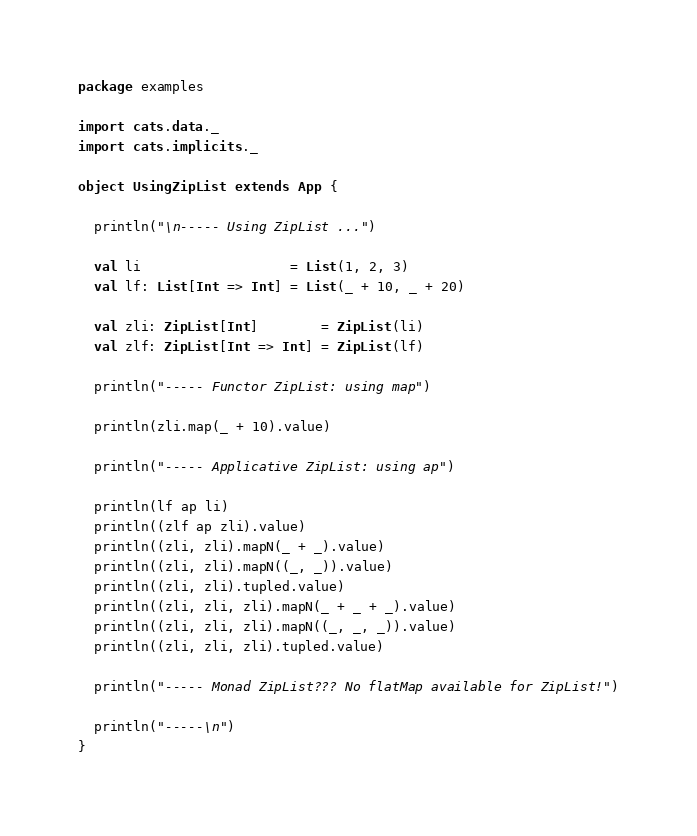<code> <loc_0><loc_0><loc_500><loc_500><_Scala_>package examples

import cats.data._
import cats.implicits._

object UsingZipList extends App {

  println("\n----- Using ZipList ...")

  val li                   = List(1, 2, 3)
  val lf: List[Int => Int] = List(_ + 10, _ + 20)

  val zli: ZipList[Int]        = ZipList(li)
  val zlf: ZipList[Int => Int] = ZipList(lf)

  println("----- Functor ZipList: using map")

  println(zli.map(_ + 10).value)

  println("----- Applicative ZipList: using ap")

  println(lf ap li)
  println((zlf ap zli).value)
  println((zli, zli).mapN(_ + _).value)
  println((zli, zli).mapN((_, _)).value)
  println((zli, zli).tupled.value)
  println((zli, zli, zli).mapN(_ + _ + _).value)
  println((zli, zli, zli).mapN((_, _, _)).value)
  println((zli, zli, zli).tupled.value)

  println("----- Monad ZipList??? No flatMap available for ZipList!")

  println("-----\n")
}
</code> 